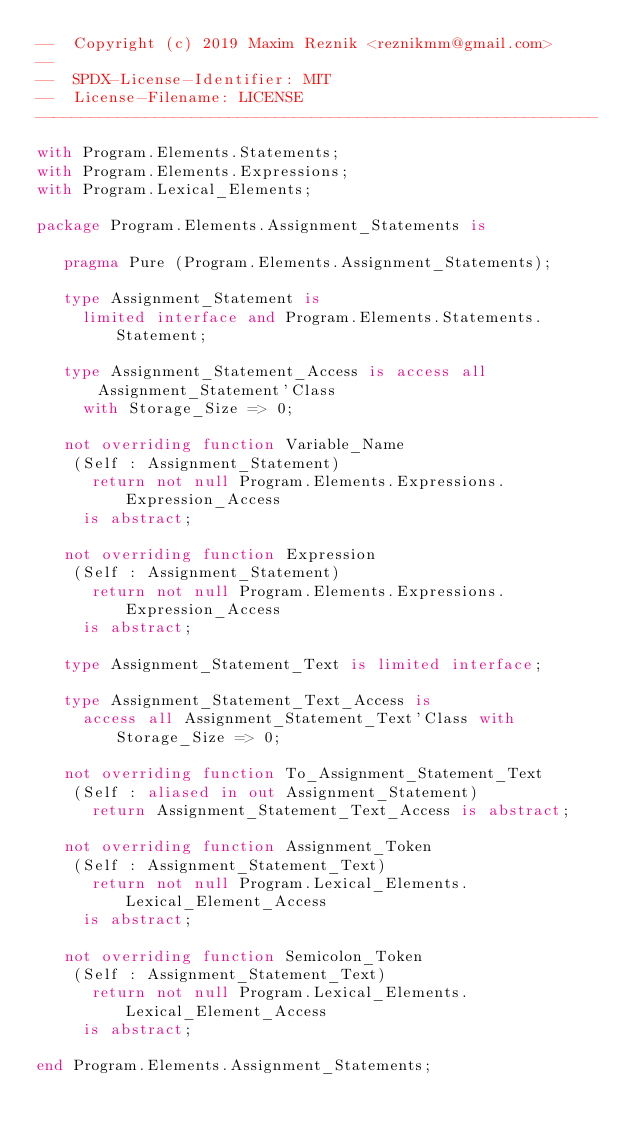Convert code to text. <code><loc_0><loc_0><loc_500><loc_500><_Ada_>--  Copyright (c) 2019 Maxim Reznik <reznikmm@gmail.com>
--
--  SPDX-License-Identifier: MIT
--  License-Filename: LICENSE
-------------------------------------------------------------

with Program.Elements.Statements;
with Program.Elements.Expressions;
with Program.Lexical_Elements;

package Program.Elements.Assignment_Statements is

   pragma Pure (Program.Elements.Assignment_Statements);

   type Assignment_Statement is
     limited interface and Program.Elements.Statements.Statement;

   type Assignment_Statement_Access is access all Assignment_Statement'Class
     with Storage_Size => 0;

   not overriding function Variable_Name
    (Self : Assignment_Statement)
      return not null Program.Elements.Expressions.Expression_Access
     is abstract;

   not overriding function Expression
    (Self : Assignment_Statement)
      return not null Program.Elements.Expressions.Expression_Access
     is abstract;

   type Assignment_Statement_Text is limited interface;

   type Assignment_Statement_Text_Access is
     access all Assignment_Statement_Text'Class with Storage_Size => 0;

   not overriding function To_Assignment_Statement_Text
    (Self : aliased in out Assignment_Statement)
      return Assignment_Statement_Text_Access is abstract;

   not overriding function Assignment_Token
    (Self : Assignment_Statement_Text)
      return not null Program.Lexical_Elements.Lexical_Element_Access
     is abstract;

   not overriding function Semicolon_Token
    (Self : Assignment_Statement_Text)
      return not null Program.Lexical_Elements.Lexical_Element_Access
     is abstract;

end Program.Elements.Assignment_Statements;
</code> 